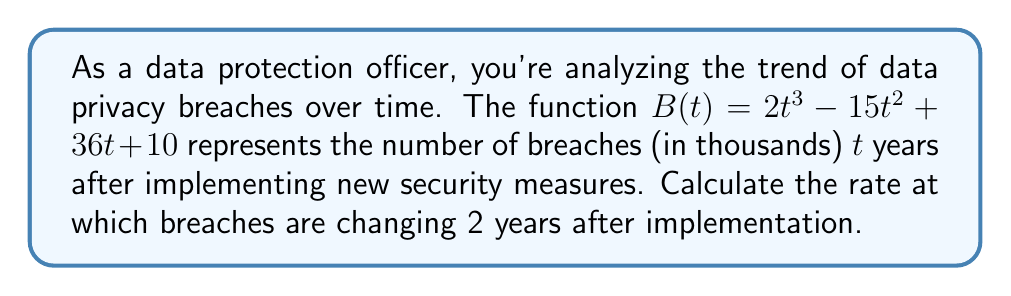Give your solution to this math problem. To solve this problem, we need to follow these steps:

1) The rate of change is represented by the derivative of the function $B(t)$.

2) Let's find the derivative $B'(t)$:
   $$B'(t) = \frac{d}{dt}(2t^3 - 15t^2 + 36t + 10)$$
   $$B'(t) = 6t^2 - 30t + 36$$

3) We need to evaluate this at $t = 2$ years:
   $$B'(2) = 6(2)^2 - 30(2) + 36$$
   $$B'(2) = 6(4) - 60 + 36$$
   $$B'(2) = 24 - 60 + 36$$
   $$B'(2) = 0$$

4) Interpret the result: The rate of change is 0 thousand breaches per year at $t = 2$ years.

This means that 2 years after implementing the new security measures, the number of breaches is momentarily neither increasing nor decreasing.
Answer: 0 thousand breaches per year 